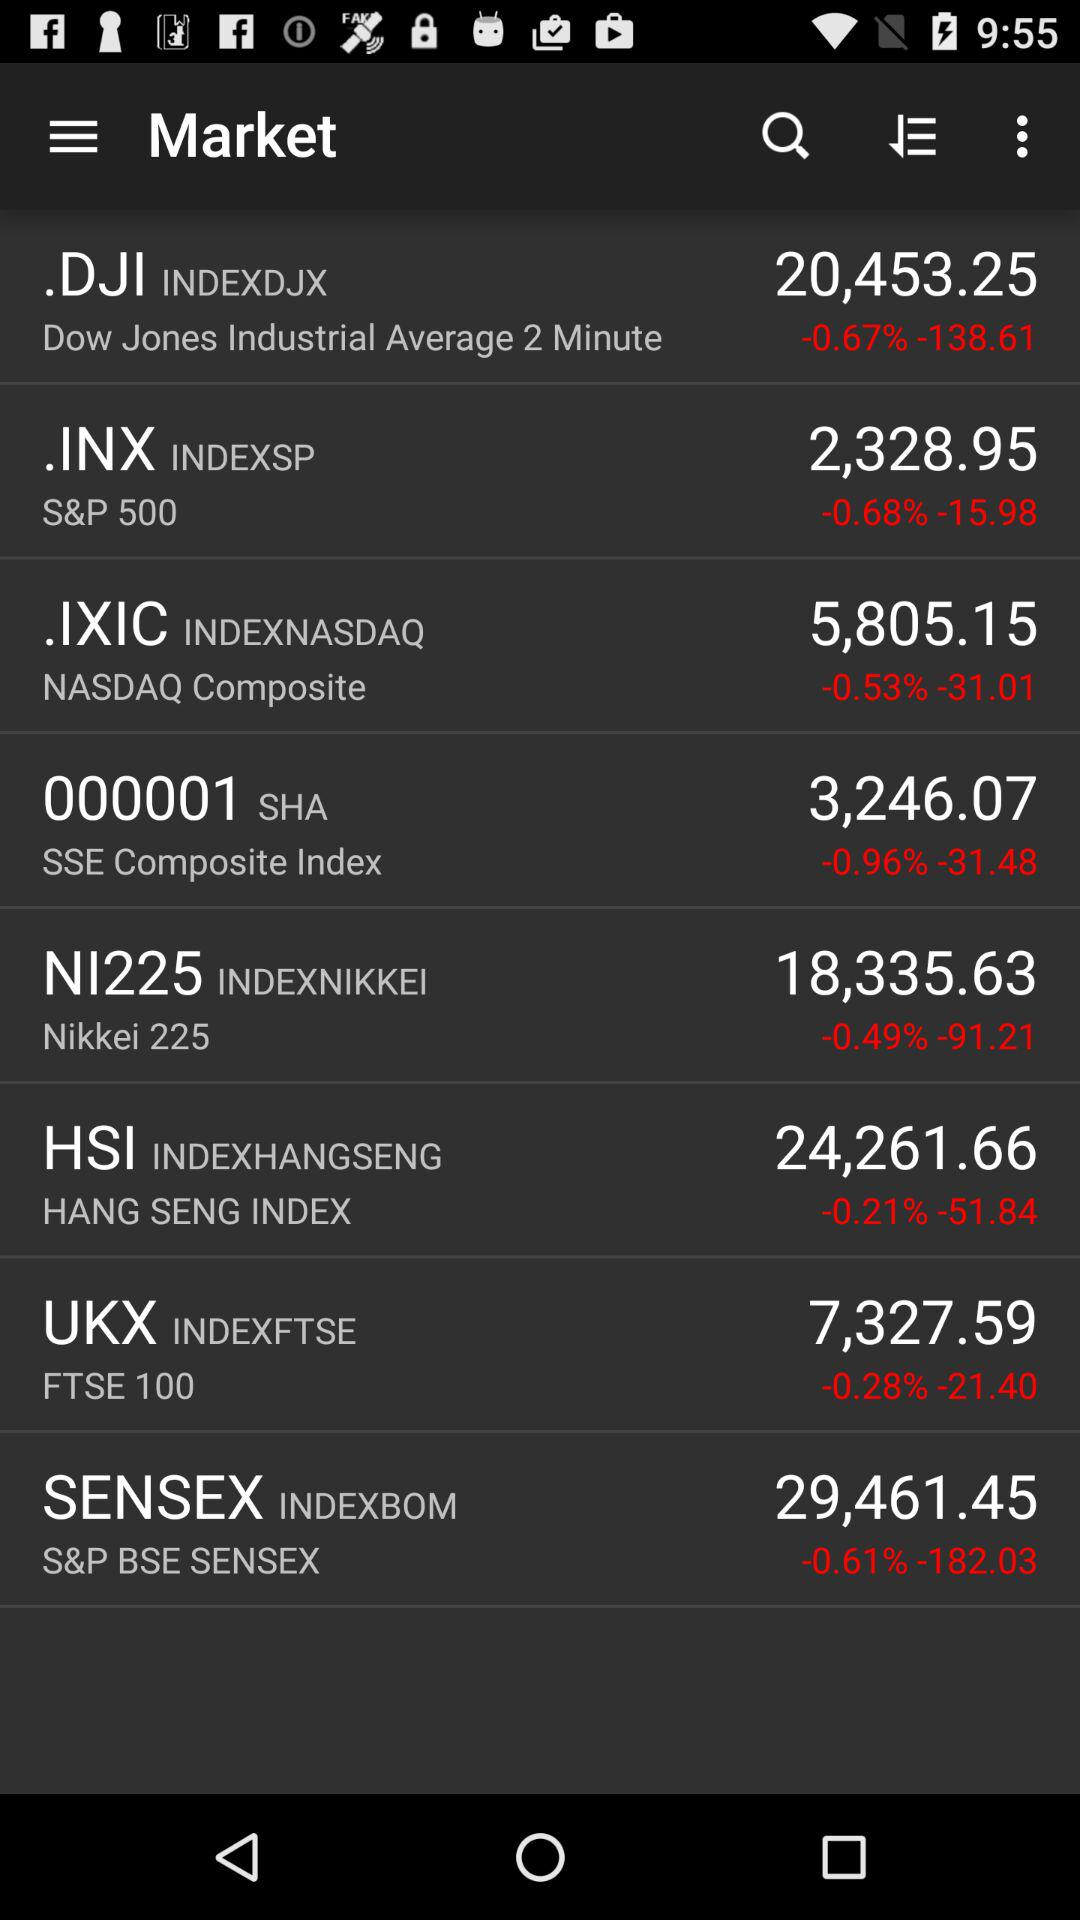What is the share price of HSI? The share price of HSI is 24,261.66. 